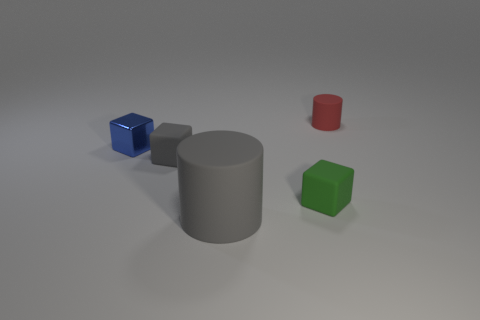What might this arrangement of objects represent or symbolize? The arrangement of geometric shapes in different colors could symbolize the diversity and unity of various elements, each with its own unique properties and characteristics. Could there be any mathematical significance to this arrangement? While it's possible to interpret mathematical relationships like proportions and ratios, this particular arrangement seems more aesthetic than mathematical. 